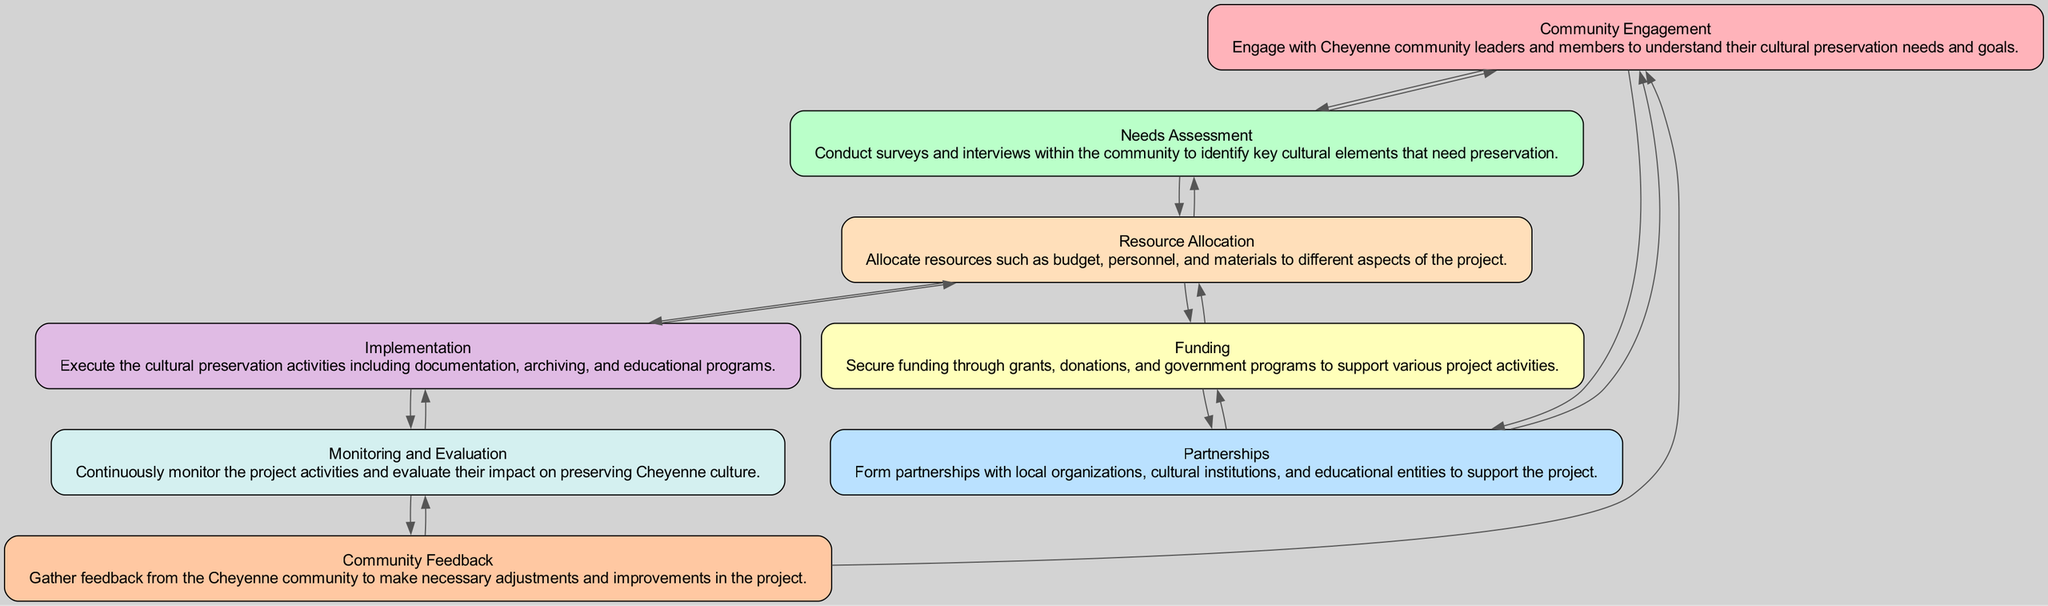What is the first step in the process? The first step mentioned in the diagram is "Community Engagement." This is the initial phase where the project engages with Cheyenne community leaders and members to understand their cultural preservation needs and goals.
Answer: Community Engagement How many nodes are in the diagram? By counting the distinct elements in the diagram data, there are a total of eight nodes representing different aspects of the cultural preservation project. Each element represents a step in the process.
Answer: 8 Which element connects to "Funding"? The "Partnerships" element connects to "Funding." This shows that establishing partnerships with local organizations and institutions is crucial for securing financial support for the project.
Answer: Partnerships What follows "Resource Allocation"? Following "Resource Allocation," the next element is "Implementation." This indicates that once resources are allocated, the project moves into executing the planned cultural preservation activities.
Answer: Implementation How does "Community Feedback" relate to the overall project? "Community Feedback" relates back to both "Monitoring and Evaluation" and "Community Engagement." This shows that feedback from the community is essential for continuously improving the project and ensuring it meets the community's needs.
Answer: Monitoring and Evaluation, Community Engagement What is allocated in "Resource Allocation"? In "Resource Allocation," the elements allocated include budget, personnel, and materials to support different aspects of the cultural preservation project. This is key for organizing and ensuring effective use of resources.
Answer: Budget, personnel, and materials Which two elements are connected to "Needs Assessment"? The two elements connected to "Needs Assessment" are "Community Engagement" and "Resource Allocation." This indicates that assessing community needs is reliant on understanding the engagement process as well as ensuring that appropriate resources are allocated for the findings.
Answer: Community Engagement, Resource Allocation What does "Monitoring and Evaluation" aim to achieve? The aim of "Monitoring and Evaluation" is to continuously oversee project activities and assess their impact on preserving Cheyenne culture. This ensures the project remains effective and aligned with its goals.
Answer: Preserving Cheyenne culture Which node has the most connections? The "Resource Allocation" node has the most connections in this diagram, linking to "Needs Assessment," "Funding," and "Implementation," indicating its central role in the project flow and various dependencies.
Answer: Resource Allocation 